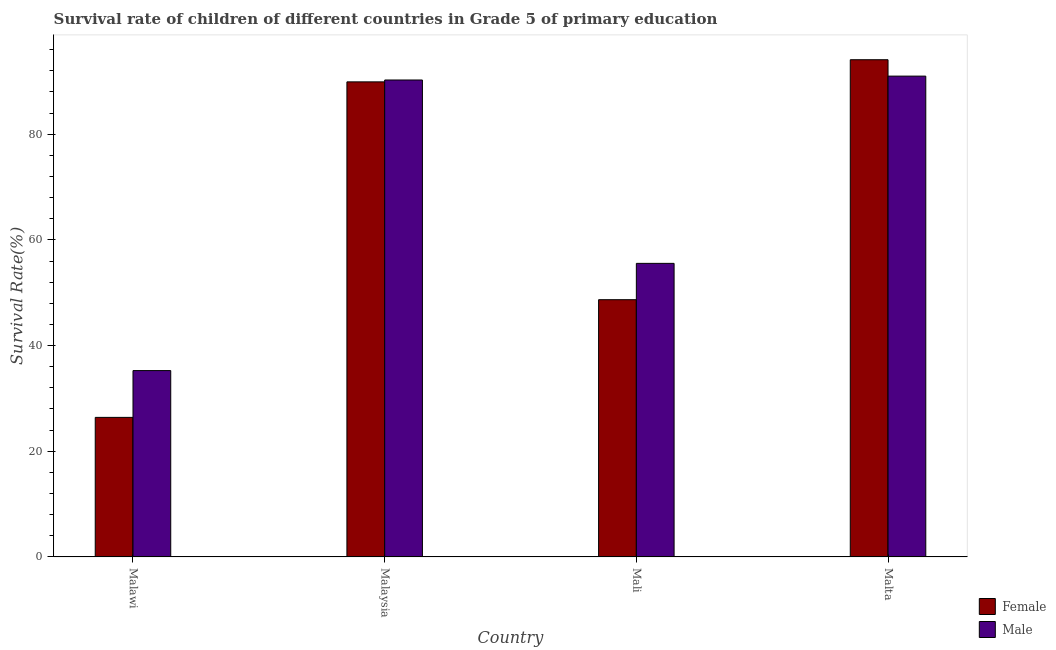How many groups of bars are there?
Keep it short and to the point. 4. Are the number of bars on each tick of the X-axis equal?
Your answer should be compact. Yes. How many bars are there on the 4th tick from the left?
Ensure brevity in your answer.  2. What is the label of the 3rd group of bars from the left?
Your answer should be compact. Mali. What is the survival rate of female students in primary education in Mali?
Provide a short and direct response. 48.68. Across all countries, what is the maximum survival rate of male students in primary education?
Your response must be concise. 90.99. Across all countries, what is the minimum survival rate of female students in primary education?
Keep it short and to the point. 26.41. In which country was the survival rate of female students in primary education maximum?
Provide a short and direct response. Malta. In which country was the survival rate of male students in primary education minimum?
Keep it short and to the point. Malawi. What is the total survival rate of female students in primary education in the graph?
Keep it short and to the point. 259.08. What is the difference between the survival rate of male students in primary education in Mali and that in Malta?
Ensure brevity in your answer.  -35.44. What is the difference between the survival rate of male students in primary education in Malaysia and the survival rate of female students in primary education in Mali?
Provide a short and direct response. 41.58. What is the average survival rate of male students in primary education per country?
Your answer should be compact. 68.02. What is the difference between the survival rate of male students in primary education and survival rate of female students in primary education in Mali?
Make the answer very short. 6.88. What is the ratio of the survival rate of female students in primary education in Malawi to that in Malaysia?
Offer a very short reply. 0.29. What is the difference between the highest and the second highest survival rate of female students in primary education?
Provide a short and direct response. 4.19. What is the difference between the highest and the lowest survival rate of female students in primary education?
Give a very brief answer. 67.69. Is the sum of the survival rate of female students in primary education in Mali and Malta greater than the maximum survival rate of male students in primary education across all countries?
Keep it short and to the point. Yes. What does the 2nd bar from the left in Malta represents?
Offer a very short reply. Male. What does the 2nd bar from the right in Mali represents?
Provide a short and direct response. Female. How many bars are there?
Offer a very short reply. 8. Are all the bars in the graph horizontal?
Offer a terse response. No. Are the values on the major ticks of Y-axis written in scientific E-notation?
Your response must be concise. No. Does the graph contain any zero values?
Your answer should be compact. No. Where does the legend appear in the graph?
Offer a very short reply. Bottom right. How many legend labels are there?
Offer a terse response. 2. How are the legend labels stacked?
Provide a succinct answer. Vertical. What is the title of the graph?
Make the answer very short. Survival rate of children of different countries in Grade 5 of primary education. Does "Under five" appear as one of the legend labels in the graph?
Offer a terse response. No. What is the label or title of the Y-axis?
Offer a terse response. Survival Rate(%). What is the Survival Rate(%) in Female in Malawi?
Offer a very short reply. 26.41. What is the Survival Rate(%) of Male in Malawi?
Your response must be concise. 35.26. What is the Survival Rate(%) in Female in Malaysia?
Make the answer very short. 89.9. What is the Survival Rate(%) in Male in Malaysia?
Your answer should be compact. 90.26. What is the Survival Rate(%) in Female in Mali?
Your answer should be very brief. 48.68. What is the Survival Rate(%) of Male in Mali?
Your answer should be very brief. 55.55. What is the Survival Rate(%) in Female in Malta?
Make the answer very short. 94.09. What is the Survival Rate(%) of Male in Malta?
Your answer should be very brief. 90.99. Across all countries, what is the maximum Survival Rate(%) in Female?
Make the answer very short. 94.09. Across all countries, what is the maximum Survival Rate(%) in Male?
Provide a short and direct response. 90.99. Across all countries, what is the minimum Survival Rate(%) of Female?
Your answer should be very brief. 26.41. Across all countries, what is the minimum Survival Rate(%) in Male?
Provide a short and direct response. 35.26. What is the total Survival Rate(%) of Female in the graph?
Ensure brevity in your answer.  259.08. What is the total Survival Rate(%) in Male in the graph?
Your answer should be compact. 272.07. What is the difference between the Survival Rate(%) in Female in Malawi and that in Malaysia?
Provide a succinct answer. -63.5. What is the difference between the Survival Rate(%) of Male in Malawi and that in Malaysia?
Your answer should be compact. -55. What is the difference between the Survival Rate(%) of Female in Malawi and that in Mali?
Offer a very short reply. -22.27. What is the difference between the Survival Rate(%) in Male in Malawi and that in Mali?
Ensure brevity in your answer.  -20.29. What is the difference between the Survival Rate(%) in Female in Malawi and that in Malta?
Offer a very short reply. -67.69. What is the difference between the Survival Rate(%) in Male in Malawi and that in Malta?
Your answer should be very brief. -55.73. What is the difference between the Survival Rate(%) in Female in Malaysia and that in Mali?
Make the answer very short. 41.22. What is the difference between the Survival Rate(%) of Male in Malaysia and that in Mali?
Ensure brevity in your answer.  34.7. What is the difference between the Survival Rate(%) in Female in Malaysia and that in Malta?
Offer a very short reply. -4.19. What is the difference between the Survival Rate(%) in Male in Malaysia and that in Malta?
Provide a succinct answer. -0.73. What is the difference between the Survival Rate(%) in Female in Mali and that in Malta?
Offer a very short reply. -45.41. What is the difference between the Survival Rate(%) in Male in Mali and that in Malta?
Offer a terse response. -35.44. What is the difference between the Survival Rate(%) in Female in Malawi and the Survival Rate(%) in Male in Malaysia?
Ensure brevity in your answer.  -63.85. What is the difference between the Survival Rate(%) in Female in Malawi and the Survival Rate(%) in Male in Mali?
Make the answer very short. -29.15. What is the difference between the Survival Rate(%) in Female in Malawi and the Survival Rate(%) in Male in Malta?
Your response must be concise. -64.59. What is the difference between the Survival Rate(%) of Female in Malaysia and the Survival Rate(%) of Male in Mali?
Your answer should be compact. 34.35. What is the difference between the Survival Rate(%) of Female in Malaysia and the Survival Rate(%) of Male in Malta?
Keep it short and to the point. -1.09. What is the difference between the Survival Rate(%) of Female in Mali and the Survival Rate(%) of Male in Malta?
Your answer should be compact. -42.31. What is the average Survival Rate(%) of Female per country?
Provide a short and direct response. 64.77. What is the average Survival Rate(%) in Male per country?
Offer a terse response. 68.02. What is the difference between the Survival Rate(%) of Female and Survival Rate(%) of Male in Malawi?
Provide a succinct answer. -8.86. What is the difference between the Survival Rate(%) in Female and Survival Rate(%) in Male in Malaysia?
Offer a very short reply. -0.36. What is the difference between the Survival Rate(%) in Female and Survival Rate(%) in Male in Mali?
Make the answer very short. -6.88. What is the difference between the Survival Rate(%) of Female and Survival Rate(%) of Male in Malta?
Ensure brevity in your answer.  3.1. What is the ratio of the Survival Rate(%) of Female in Malawi to that in Malaysia?
Your response must be concise. 0.29. What is the ratio of the Survival Rate(%) in Male in Malawi to that in Malaysia?
Offer a very short reply. 0.39. What is the ratio of the Survival Rate(%) in Female in Malawi to that in Mali?
Make the answer very short. 0.54. What is the ratio of the Survival Rate(%) in Male in Malawi to that in Mali?
Make the answer very short. 0.63. What is the ratio of the Survival Rate(%) in Female in Malawi to that in Malta?
Ensure brevity in your answer.  0.28. What is the ratio of the Survival Rate(%) of Male in Malawi to that in Malta?
Provide a short and direct response. 0.39. What is the ratio of the Survival Rate(%) of Female in Malaysia to that in Mali?
Ensure brevity in your answer.  1.85. What is the ratio of the Survival Rate(%) in Male in Malaysia to that in Mali?
Ensure brevity in your answer.  1.62. What is the ratio of the Survival Rate(%) in Female in Malaysia to that in Malta?
Keep it short and to the point. 0.96. What is the ratio of the Survival Rate(%) of Female in Mali to that in Malta?
Provide a succinct answer. 0.52. What is the ratio of the Survival Rate(%) of Male in Mali to that in Malta?
Provide a short and direct response. 0.61. What is the difference between the highest and the second highest Survival Rate(%) in Female?
Your response must be concise. 4.19. What is the difference between the highest and the second highest Survival Rate(%) in Male?
Make the answer very short. 0.73. What is the difference between the highest and the lowest Survival Rate(%) in Female?
Provide a short and direct response. 67.69. What is the difference between the highest and the lowest Survival Rate(%) of Male?
Give a very brief answer. 55.73. 